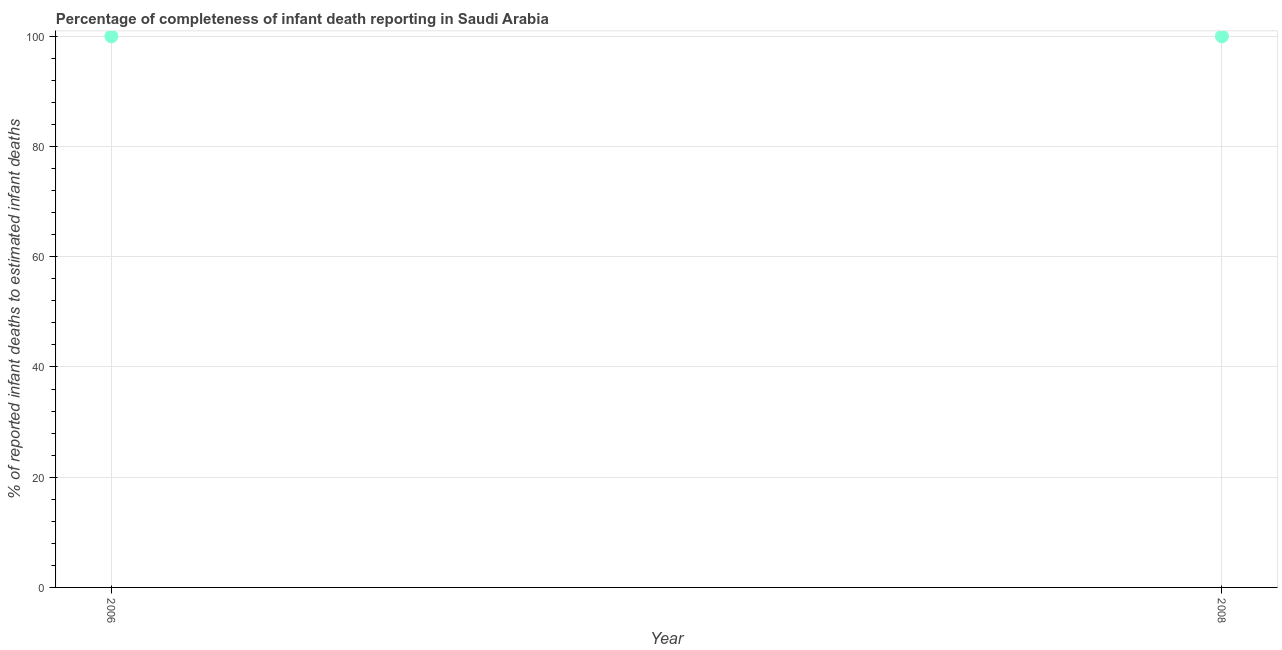What is the completeness of infant death reporting in 2006?
Your answer should be compact. 100. Across all years, what is the maximum completeness of infant death reporting?
Keep it short and to the point. 100. Across all years, what is the minimum completeness of infant death reporting?
Make the answer very short. 100. In which year was the completeness of infant death reporting minimum?
Your answer should be very brief. 2006. What is the sum of the completeness of infant death reporting?
Keep it short and to the point. 200. What is the difference between the completeness of infant death reporting in 2006 and 2008?
Provide a succinct answer. 0. What is the median completeness of infant death reporting?
Offer a very short reply. 100. What is the ratio of the completeness of infant death reporting in 2006 to that in 2008?
Make the answer very short. 1. Is the completeness of infant death reporting in 2006 less than that in 2008?
Ensure brevity in your answer.  No. What is the difference between two consecutive major ticks on the Y-axis?
Your answer should be very brief. 20. Are the values on the major ticks of Y-axis written in scientific E-notation?
Ensure brevity in your answer.  No. Does the graph contain any zero values?
Your response must be concise. No. What is the title of the graph?
Offer a terse response. Percentage of completeness of infant death reporting in Saudi Arabia. What is the label or title of the Y-axis?
Your answer should be compact. % of reported infant deaths to estimated infant deaths. What is the % of reported infant deaths to estimated infant deaths in 2008?
Your answer should be very brief. 100. What is the difference between the % of reported infant deaths to estimated infant deaths in 2006 and 2008?
Offer a very short reply. 0. What is the ratio of the % of reported infant deaths to estimated infant deaths in 2006 to that in 2008?
Your response must be concise. 1. 